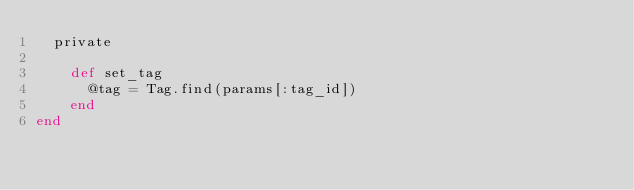Convert code to text. <code><loc_0><loc_0><loc_500><loc_500><_Ruby_>  private

    def set_tag
      @tag = Tag.find(params[:tag_id])
    end
end
</code> 